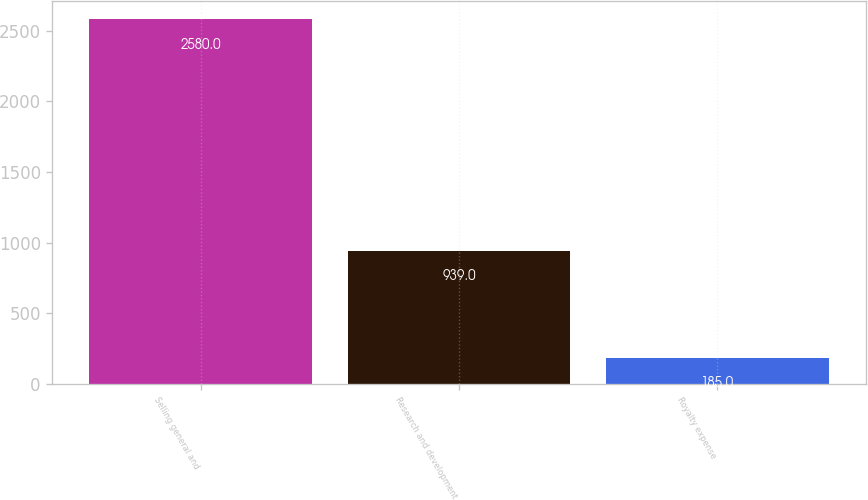<chart> <loc_0><loc_0><loc_500><loc_500><bar_chart><fcel>Selling general and<fcel>Research and development<fcel>Royalty expense<nl><fcel>2580<fcel>939<fcel>185<nl></chart> 